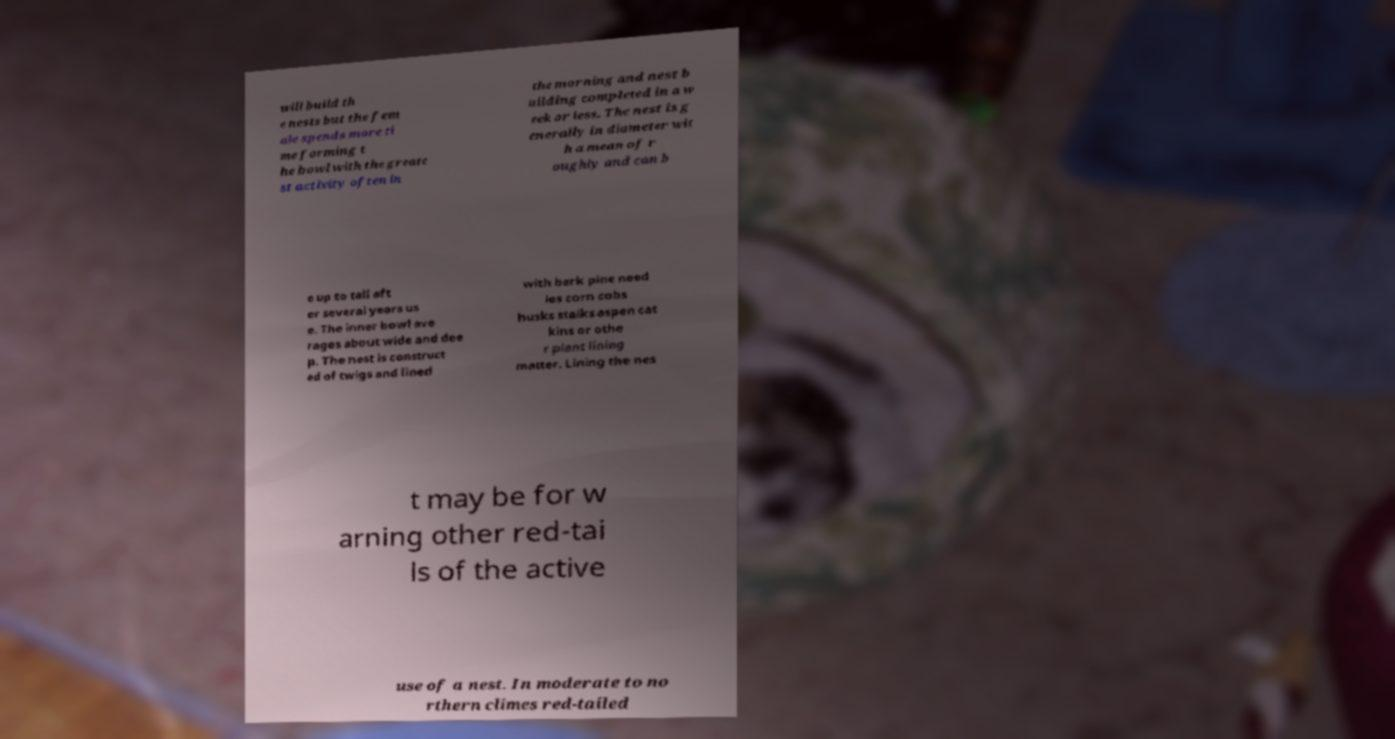Can you accurately transcribe the text from the provided image for me? will build th e nests but the fem ale spends more ti me forming t he bowl with the greate st activity often in the morning and nest b uilding completed in a w eek or less. The nest is g enerally in diameter wit h a mean of r oughly and can b e up to tall aft er several years us e. The inner bowl ave rages about wide and dee p. The nest is construct ed of twigs and lined with bark pine need les corn cobs husks stalks aspen cat kins or othe r plant lining matter. Lining the nes t may be for w arning other red-tai ls of the active use of a nest. In moderate to no rthern climes red-tailed 